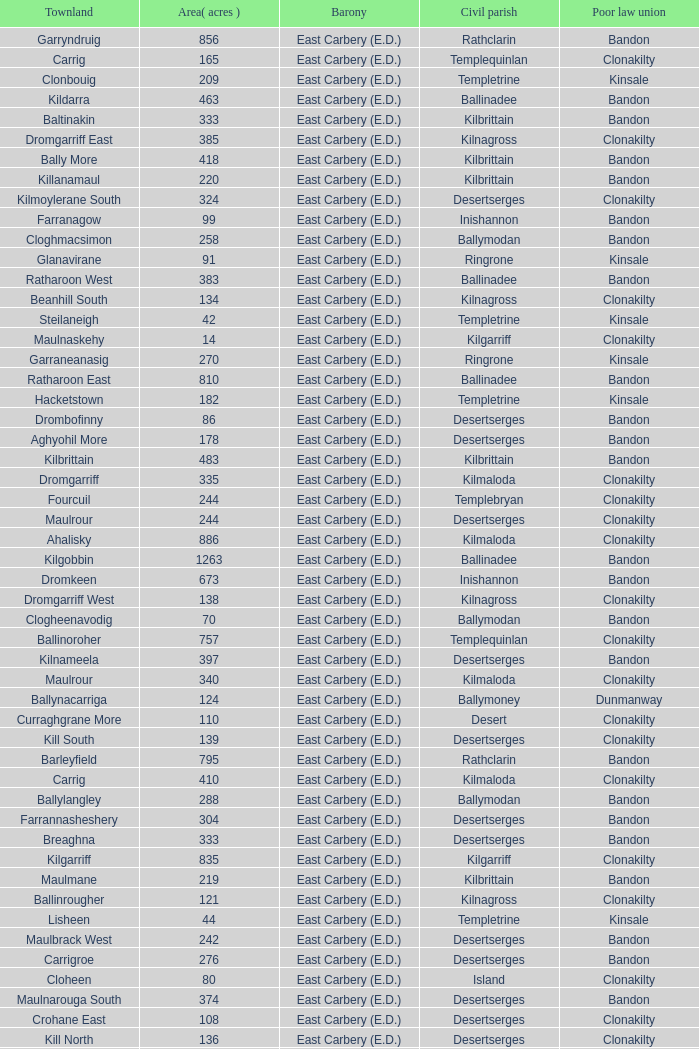What is the poor law union of the Ardacrow townland? Bandon. Could you help me parse every detail presented in this table? {'header': ['Townland', 'Area( acres )', 'Barony', 'Civil parish', 'Poor law union'], 'rows': [['Garryndruig', '856', 'East Carbery (E.D.)', 'Rathclarin', 'Bandon'], ['Carrig', '165', 'East Carbery (E.D.)', 'Templequinlan', 'Clonakilty'], ['Clonbouig', '209', 'East Carbery (E.D.)', 'Templetrine', 'Kinsale'], ['Kildarra', '463', 'East Carbery (E.D.)', 'Ballinadee', 'Bandon'], ['Baltinakin', '333', 'East Carbery (E.D.)', 'Kilbrittain', 'Bandon'], ['Dromgarriff East', '385', 'East Carbery (E.D.)', 'Kilnagross', 'Clonakilty'], ['Bally More', '418', 'East Carbery (E.D.)', 'Kilbrittain', 'Bandon'], ['Killanamaul', '220', 'East Carbery (E.D.)', 'Kilbrittain', 'Bandon'], ['Kilmoylerane South', '324', 'East Carbery (E.D.)', 'Desertserges', 'Clonakilty'], ['Farranagow', '99', 'East Carbery (E.D.)', 'Inishannon', 'Bandon'], ['Cloghmacsimon', '258', 'East Carbery (E.D.)', 'Ballymodan', 'Bandon'], ['Glanavirane', '91', 'East Carbery (E.D.)', 'Ringrone', 'Kinsale'], ['Ratharoon West', '383', 'East Carbery (E.D.)', 'Ballinadee', 'Bandon'], ['Beanhill South', '134', 'East Carbery (E.D.)', 'Kilnagross', 'Clonakilty'], ['Steilaneigh', '42', 'East Carbery (E.D.)', 'Templetrine', 'Kinsale'], ['Maulnaskehy', '14', 'East Carbery (E.D.)', 'Kilgarriff', 'Clonakilty'], ['Garraneanasig', '270', 'East Carbery (E.D.)', 'Ringrone', 'Kinsale'], ['Ratharoon East', '810', 'East Carbery (E.D.)', 'Ballinadee', 'Bandon'], ['Hacketstown', '182', 'East Carbery (E.D.)', 'Templetrine', 'Kinsale'], ['Drombofinny', '86', 'East Carbery (E.D.)', 'Desertserges', 'Bandon'], ['Aghyohil More', '178', 'East Carbery (E.D.)', 'Desertserges', 'Bandon'], ['Kilbrittain', '483', 'East Carbery (E.D.)', 'Kilbrittain', 'Bandon'], ['Dromgarriff', '335', 'East Carbery (E.D.)', 'Kilmaloda', 'Clonakilty'], ['Fourcuil', '244', 'East Carbery (E.D.)', 'Templebryan', 'Clonakilty'], ['Maulrour', '244', 'East Carbery (E.D.)', 'Desertserges', 'Clonakilty'], ['Ahalisky', '886', 'East Carbery (E.D.)', 'Kilmaloda', 'Clonakilty'], ['Kilgobbin', '1263', 'East Carbery (E.D.)', 'Ballinadee', 'Bandon'], ['Dromkeen', '673', 'East Carbery (E.D.)', 'Inishannon', 'Bandon'], ['Dromgarriff West', '138', 'East Carbery (E.D.)', 'Kilnagross', 'Clonakilty'], ['Clogheenavodig', '70', 'East Carbery (E.D.)', 'Ballymodan', 'Bandon'], ['Ballinoroher', '757', 'East Carbery (E.D.)', 'Templequinlan', 'Clonakilty'], ['Kilnameela', '397', 'East Carbery (E.D.)', 'Desertserges', 'Bandon'], ['Maulrour', '340', 'East Carbery (E.D.)', 'Kilmaloda', 'Clonakilty'], ['Ballynacarriga', '124', 'East Carbery (E.D.)', 'Ballymoney', 'Dunmanway'], ['Curraghgrane More', '110', 'East Carbery (E.D.)', 'Desert', 'Clonakilty'], ['Kill South', '139', 'East Carbery (E.D.)', 'Desertserges', 'Clonakilty'], ['Barleyfield', '795', 'East Carbery (E.D.)', 'Rathclarin', 'Bandon'], ['Carrig', '410', 'East Carbery (E.D.)', 'Kilmaloda', 'Clonakilty'], ['Ballylangley', '288', 'East Carbery (E.D.)', 'Ballymodan', 'Bandon'], ['Farrannasheshery', '304', 'East Carbery (E.D.)', 'Desertserges', 'Bandon'], ['Breaghna', '333', 'East Carbery (E.D.)', 'Desertserges', 'Bandon'], ['Kilgarriff', '835', 'East Carbery (E.D.)', 'Kilgarriff', 'Clonakilty'], ['Maulmane', '219', 'East Carbery (E.D.)', 'Kilbrittain', 'Bandon'], ['Ballinrougher', '121', 'East Carbery (E.D.)', 'Kilnagross', 'Clonakilty'], ['Lisheen', '44', 'East Carbery (E.D.)', 'Templetrine', 'Kinsale'], ['Maulbrack West', '242', 'East Carbery (E.D.)', 'Desertserges', 'Bandon'], ['Carrigroe', '276', 'East Carbery (E.D.)', 'Desertserges', 'Bandon'], ['Cloheen', '80', 'East Carbery (E.D.)', 'Island', 'Clonakilty'], ['Maulnarouga South', '374', 'East Carbery (E.D.)', 'Desertserges', 'Bandon'], ['Crohane East', '108', 'East Carbery (E.D.)', 'Desertserges', 'Clonakilty'], ['Kill North', '136', 'East Carbery (E.D.)', 'Desertserges', 'Clonakilty'], ['Kilmacsimon', '219', 'East Carbery (E.D.)', 'Ballinadee', 'Bandon'], ['Rockfort', '308', 'East Carbery (E.D.)', 'Brinny', 'Bandon'], ['Knocknanuss', '394', 'East Carbery (E.D.)', 'Desertserges', 'Clonakilty'], ['Currabeg', '173', 'East Carbery (E.D.)', 'Ballymoney', 'Dunmanway'], ['Shanaway West', '266', 'East Carbery (E.D.)', 'Ballymoney', 'Dunmanway'], ['Cripplehill', '93', 'East Carbery (E.D.)', 'Kilbrittain', 'Bandon'], ['Maulnarouga North', '81', 'East Carbery (E.D.)', 'Desertserges', 'Bandon'], ['Skeaf', '452', 'East Carbery (E.D.)', 'Kilmaloda', 'Clonakilty'], ['Cripplehill', '125', 'East Carbery (E.D.)', 'Ballymodan', 'Bandon'], ['Garranecore', '144', 'East Carbery (E.D.)', 'Templebryan', 'Clonakilty'], ['Ballinadee', '329', 'East Carbery (E.D.)', 'Ballinadee', 'Bandon'], ['Derrymeeleen', '441', 'East Carbery (E.D.)', 'Desertserges', 'Clonakilty'], ['Knockmacool', '241', 'East Carbery (E.D.)', 'Desertserges', 'Bandon'], ['Killeens', '132', 'East Carbery (E.D.)', 'Templetrine', 'Kinsale'], ['Glanduff', '464', 'East Carbery (E.D.)', 'Rathclarin', 'Bandon'], ['Artiteige', '337', 'East Carbery (E.D.)', 'Templetrine', 'Kinsale'], ['Ardkitt East', '283', 'East Carbery (E.D.)', 'Desertserges', 'Bandon'], ['Rathdrought', '1242', 'East Carbery (E.D.)', 'Ballinadee', 'Bandon'], ['Cloghane', '488', 'East Carbery (E.D.)', 'Ballinadee', 'Bandon'], ['Aghyohil Beg', '94', 'East Carbery (E.D.)', 'Desertserges', 'Bandon'], ['Templebryan North', '436', 'East Carbery (E.D.)', 'Templebryan', 'Clonakilty'], ['Garranereagh', '398', 'East Carbery (E.D.)', 'Ringrone', 'Kinsale'], ['Crohane (or Bandon)', '250', 'East Carbery (E.D.)', 'Kilnagross', 'Clonakilty'], ['Killaneetig', '342', 'East Carbery (E.D.)', 'Ballinadee', 'Bandon'], ['Knocknastooka', '118', 'East Carbery (E.D.)', 'Desertserges', 'Bandon'], ['Ardacrow', '519', 'East Carbery (E.D.)', 'Rathclarin', 'Bandon'], ['Shanaway Middle', '296', 'East Carbery (E.D.)', 'Ballymoney', 'Dunmanway'], ['Lisroe', '91', 'East Carbery (E.D.)', 'Kilgarriff', 'Clonakilty'], ['Ardkitt West', '407', 'East Carbery (E.D.)', 'Desertserges', 'Bandon'], ['Crohane', '91', 'East Carbery (E.D.)', 'Kilnagross', 'Clonakilty'], ['Kilmoylerane North', '306', 'East Carbery (E.D.)', 'Desertserges', 'Clonakilty'], ['Ballyvoige', '278', 'East Carbery (E.D.)', 'Desertserges', 'Clonakilty'], ['Youghals', '109', 'East Carbery (E.D.)', 'Island', 'Clonakilty'], ['Knockeenbwee Lower', '213', 'East Carbery (E.D.)', 'Dromdaleague', 'Skibbereen'], ['Derrigra West', '320', 'East Carbery (E.D.)', 'Ballymoney', 'Dunmanway'], ['Reengarrigeen', '560', 'East Carbery (E.D.)', 'Kilmaloda', 'Clonakilty'], ['Clooncalla Beg', '219', 'East Carbery (E.D.)', 'Rathclarin', 'Bandon'], ['Edencurra', '516', 'East Carbery (E.D.)', 'Ballymoney', 'Dunmanway'], ['Knockskagh', '489', 'East Carbery (E.D.)', 'Kilgarriff', 'Clonakilty'], ['Garraneishal', '121', 'East Carbery (E.D.)', 'Kilnagross', 'Clonakilty'], ['Moanarone', '235', 'East Carbery (E.D.)', 'Ballymodan', 'Bandon'], ['Burrane', '410', 'East Carbery (E.D.)', 'Kilmaloda', 'Clonakilty'], ['Cashelisky', '368', 'East Carbery (E.D.)', 'Island', 'Clonakilty'], ['Tawnies Lower', '238', 'East Carbery (E.D.)', 'Kilgarriff', 'Clonakilty'], ['Rockhouse', '82', 'East Carbery (E.D.)', 'Ballinadee', 'Bandon'], ['Ballycatteen', '338', 'East Carbery (E.D.)', 'Rathclarin', 'Bandon'], ['Ballymountain', '533', 'East Carbery (E.D.)', 'Inishannon', 'Bandon'], ['Scartagh', '186', 'East Carbery (E.D.)', 'Kilgarriff', 'Clonakilty'], ['Tullymurrihy', '665', 'East Carbery (E.D.)', 'Desertserges', 'Bandon'], ['Farrannagark', '290', 'East Carbery (E.D.)', 'Rathclarin', 'Bandon'], ['Crohane (or Bandon)', '204', 'East Carbery (E.D.)', 'Desertserges', 'Clonakilty'], ['Derry', '140', 'East Carbery (E.D.)', 'Desertserges', 'Clonakilty'], ['Ballynascubbig', '272', 'East Carbery (E.D.)', 'Templetrine', 'Kinsale'], ['Derrigra', '177', 'East Carbery (E.D.)', 'Ballymoney', 'Dunmanway'], ['Garraneard', '276', 'East Carbery (E.D.)', 'Kilnagross', 'Clonakilty'], ['Curranure', '362', 'East Carbery (E.D.)', 'Inishannon', 'Bandon'], ['Knockeenbwee Upper', '229', 'East Carbery (E.D.)', 'Dromdaleague', 'Skibbereen'], ['Kilbeloge', '216', 'East Carbery (E.D.)', 'Desertserges', 'Clonakilty'], ['Crohane West', '69', 'East Carbery (E.D.)', 'Desertserges', 'Clonakilty'], ['Lackenagobidane', '48', 'East Carbery (E.D.)', 'Island', 'Clonakilty'], ['Killavarrig', '708', 'East Carbery (E.D.)', 'Timoleague', 'Clonakilty'], ['Miles', '268', 'East Carbery (E.D.)', 'Kilgarriff', 'Clonakilty'], ['Ballydownis East', '42', 'East Carbery (E.D.)', 'Templetrine', 'Kinsale'], ['Kilvurra', '356', 'East Carbery (E.D.)', 'Ballymoney', 'Dunmanway'], ['Knockaneroe', '127', 'East Carbery (E.D.)', 'Templetrine', 'Kinsale'], ['Knockanreagh', '139', 'East Carbery (E.D.)', 'Ballymodan', 'Bandon'], ['Curraghcrowly East', '327', 'East Carbery (E.D.)', 'Ballymoney', 'Dunmanway'], ['Ballyvolane', '333', 'East Carbery (E.D.)', 'Ballinadee', 'Bandon'], ['Kilcaskan', '221', 'East Carbery (E.D.)', 'Ballymoney', 'Dunmanway'], ['Phale Lower', '287', 'East Carbery (E.D.)', 'Ballymoney', 'Dunmanway'], ['Clooncalla More', '543', 'East Carbery (E.D.)', 'Rathclarin', 'Bandon'], ['Cloheen', '360', 'East Carbery (E.D.)', 'Kilgarriff', 'Clonakilty'], ['Maulnageragh', '135', 'East Carbery (E.D.)', 'Kilnagross', 'Clonakilty'], ['Lisnacunna', '529', 'East Carbery (E.D.)', 'Desertserges', 'Bandon'], ['Bawnea', '112', 'East Carbery (E.D.)', 'Templetrine', 'Kinsale'], ['Cloonderreen', '291', 'East Carbery (E.D.)', 'Rathclarin', 'Bandon'], ['Knocknagappul', '507', 'East Carbery (E.D.)', 'Ballinadee', 'Bandon'], ['Tullyland', '348', 'East Carbery (E.D.)', 'Ballymodan', 'Bandon'], ['Currane', '156', 'East Carbery (E.D.)', 'Desertserges', 'Clonakilty'], ['Inchafune', '871', 'East Carbery (E.D.)', 'Ballymoney', 'Dunmanway'], ['Ballymacowen', '522', 'East Carbery (E.D.)', 'Kilnagross', 'Clonakilty'], ['Killeen', '309', 'East Carbery (E.D.)', 'Desertserges', 'Clonakilty'], ['Coolmain', '450', 'East Carbery (E.D.)', 'Ringrone', 'Kinsale'], ['Currarane', '100', 'East Carbery (E.D.)', 'Templetrine', 'Kinsale'], ['Glanavaud', '98', 'East Carbery (E.D.)', 'Ringrone', 'Kinsale'], ['Currarane', '271', 'East Carbery (E.D.)', 'Ringrone', 'Kinsale'], ['Lisheenaleen', '267', 'East Carbery (E.D.)', 'Rathclarin', 'Bandon'], ['Knockeencon', '108', 'East Carbery (E.D.)', 'Tullagh', 'Skibbereen'], ['Glanavirane', '107', 'East Carbery (E.D.)', 'Templetrine', 'Kinsale'], ['Rochestown', '104', 'East Carbery (E.D.)', 'Templetrine', 'Kinsale'], ['Carhoovauler', '561', 'East Carbery (E.D.)', 'Desertserges', 'Clonakilty'], ['Castlederry', '148', 'East Carbery (E.D.)', 'Desertserges', 'Clonakilty'], ['Baurleigh', '885', 'East Carbery (E.D.)', 'Kilbrittain', 'Bandon'], ['Kilbree', '284', 'East Carbery (E.D.)', 'Island', 'Clonakilty'], ['Carrigcannon', '59', 'East Carbery (E.D.)', 'Ballymodan', 'Bandon'], ['Kilshinahan', '528', 'East Carbery (E.D.)', 'Kilbrittain', 'Bandon'], ['Skeaf East', '371', 'East Carbery (E.D.)', 'Kilmaloda', 'Clonakilty'], ['Templebryan South', '363', 'East Carbery (E.D.)', 'Templebryan', 'Clonakilty'], ['Knockaneady', '393', 'East Carbery (E.D.)', 'Ballymoney', 'Dunmanway'], ['Grillagh', '136', 'East Carbery (E.D.)', 'Kilnagross', 'Clonakilty'], ['Cloncouse', '241', 'East Carbery (E.D.)', 'Ballinadee', 'Bandon'], ['Shanaway East', '386', 'East Carbery (E.D.)', 'Ballymoney', 'Dunmanway'], ['Ballinard', '589', 'East Carbery (E.D.)', 'Desertserges', 'Clonakilty'], ['Garranelahan', '126', 'East Carbery (E.D.)', 'Desertserges', 'Bandon'], ['Knockbrown', '510', 'East Carbery (E.D.)', 'Kilmaloda', 'Bandon'], ['Ballydownis West', '60', 'East Carbery (E.D.)', 'Templetrine', 'Kinsale'], ['Carriganookery', '94', 'East Carbery (E.D.)', 'Kilnagross', 'Clonakilty'], ['Phale Upper', '234', 'East Carbery (E.D.)', 'Ballymoney', 'Dunmanway'], ['Ballybeg', '261', 'East Carbery (E.D.)', 'Kilbrittain', 'Bandon'], ['Knockacullen', '381', 'East Carbery (E.D.)', 'Desertserges', 'Clonakilty'], ['Cappeen', '36', 'East Carbery (E.D.)', 'Kilgarriff', 'Clonakilty'], ['Lissaphooca', '513', 'East Carbery (E.D.)', 'Ballymodan', 'Bandon'], ['Maulbrack East', '100', 'East Carbery (E.D.)', 'Desertserges', 'Bandon'], ['Ardea', '295', 'East Carbery (E.D.)', 'Ballymoney', 'Dunmanway'], ['Knockbrown', '312', 'East Carbery (E.D.)', 'Kilbrittain', 'Bandon'], ['Madame', '273', 'East Carbery (E.D.)', 'Kilmaloda', 'Clonakilty'], ['Desert', '339', 'East Carbery (E.D.)', 'Desert', 'Clonakilty'], ['Skeaf West', '477', 'East Carbery (E.D.)', 'Kilmaloda', 'Clonakilty'], ['Lisbehegh', '255', 'East Carbery (E.D.)', 'Desertserges', 'Clonakilty'], ['Carrigcannon', '122', 'East Carbery (E.D.)', 'Ringrone', 'Kinsale'], ['Corravreeda West', '169', 'East Carbery (E.D.)', 'Ballymodan', 'Bandon'], ['Shanakill', '197', 'East Carbery (E.D.)', 'Rathclarin', 'Bandon'], ['Tullyland', '506', 'East Carbery (E.D.)', 'Ballinadee', 'Bandon'], ['Clashreagh', '132', 'East Carbery (E.D.)', 'Templetrine', 'Kinsale'], ['Knocknacurra', '422', 'East Carbery (E.D.)', 'Ballinadee', 'Bandon'], ['Clashafree', '477', 'East Carbery (E.D.)', 'Ballymodan', 'Bandon'], ['Knockroe', '601', 'East Carbery (E.D.)', 'Inishannon', 'Bandon'], ['Buddrimeen', '227', 'East Carbery (E.D.)', 'Ballymoney', 'Dunmanway'], ['Garranes', '416', 'East Carbery (E.D.)', 'Desertserges', 'Clonakilty'], ['Tullig', '135', 'East Carbery (E.D.)', 'Kilmaloda', 'Clonakilty'], ['Knoppoge', '567', 'East Carbery (E.D.)', 'Kilbrittain', 'Bandon'], ['Madame', '41', 'East Carbery (E.D.)', 'Kilnagross', 'Clonakilty'], ['Farran', '502', 'East Carbery (E.D.)', 'Kilmaloda', 'Clonakilty'], ['Bawnea', '355', 'East Carbery (E.D.)', 'Ringrone', 'Kinsale'], ['Ballydownis', '73', 'East Carbery (E.D.)', 'Ringrone', 'Kinsale'], ['Tawnies Upper', '321', 'East Carbery (E.D.)', 'Kilgarriff', 'Clonakilty'], ['Curraghcrowly West', '242', 'East Carbery (E.D.)', 'Ballymoney', 'Dunmanway'], ['Garranbeg', '170', 'East Carbery (E.D.)', 'Ballymodan', 'Bandon'], ['Corravreeda East', '258', 'East Carbery (E.D.)', 'Ballymodan', 'Bandon'], ['Reenroe', '123', 'East Carbery (E.D.)', 'Kilgarriff', 'Clonakilty'], ['Burren', '639', 'East Carbery (E.D.)', 'Rathclarin', 'Bandon'], ['Monteen', '589', 'East Carbery (E.D.)', 'Kilmaloda', 'Clonakilty'], ['Garranecore', '186', 'East Carbery (E.D.)', 'Kilgarriff', 'Clonakilty'], ['Kilrush', '189', 'East Carbery (E.D.)', 'Desertserges', 'Bandon'], ['Clogagh South', '282', 'East Carbery (E.D.)', 'Kilmaloda', 'Clonakilty'], ['Garranure', '436', 'East Carbery (E.D.)', 'Ballymoney', 'Dunmanway'], ['Kilmaloda', '634', 'East Carbery (E.D.)', 'Kilmaloda', 'Clonakilty'], ['Beanhill North', '108', 'East Carbery (E.D.)', 'Kilnagross', 'Clonakilty'], ['Ardnaclug', '202', 'East Carbery (E.D.)', 'Inishannon', 'Bandon'], ['Clogagh North', '173', 'East Carbery (E.D.)', 'Kilmaloda', 'Clonakilty'], ['Maulskinlahane', '245', 'East Carbery (E.D.)', 'Kilbrittain', 'Bandon'], ['Grillagh', '316', 'East Carbery (E.D.)', 'Ballymoney', 'Dunmanway'], ['Lackanalooha', '209', 'East Carbery (E.D.)', 'Kilnagross', 'Clonakilty'], ['Lisselane', '429', 'East Carbery (E.D.)', 'Kilnagross', 'Clonakilty'], ['Ballinvronig', '319', 'East Carbery (E.D.)', 'Templetrine', 'Kinsale'], ['Bunanumera', '232', 'East Carbery (E.D.)', 'Ballymoney', 'Dunmanway'], ['Fourcuil', '125', 'East Carbery (E.D.)', 'Kilgarriff', 'Clonakilty'], ['Inchydoney Island', '474', 'East Carbery (E.D.)', 'Island', 'Clonakilty'], ['Carhoogarriff', '281', 'East Carbery (E.D.)', 'Kilnagross', 'Clonakilty'], ['Garranefeen', '478', 'East Carbery (E.D.)', 'Rathclarin', 'Bandon'], ['Kilvinane', '199', 'East Carbery (E.D.)', 'Ballymoney', 'Dunmanway'], ['Knocks', '540', 'East Carbery (E.D.)', 'Desertserges', 'Clonakilty'], ['Carrigeen', '210', 'East Carbery (E.D.)', 'Ballymoney', 'Dunmanway'], ['Skevanish', '359', 'East Carbery (E.D.)', 'Inishannon', 'Bandon'], ['Glan', '194', 'East Carbery (E.D.)', 'Ballymoney', 'Dunmanway'], ['Clonbouig', '219', 'East Carbery (E.D.)', 'Ringrone', 'Kinsale'], ['Boulteen', '212', 'East Carbery (E.D.)', 'Desertserges', 'Bandon']]} 